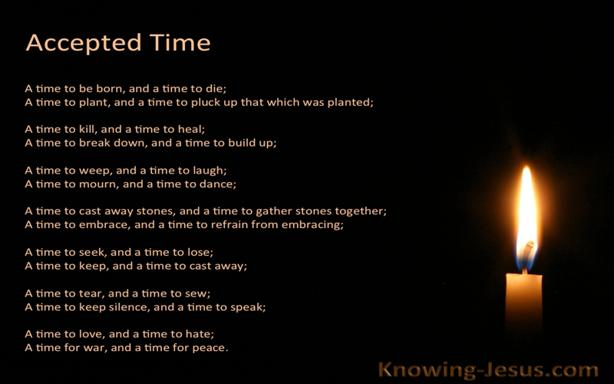What might be the intention behind the visual layout of this image? The stark simplicity of the visual layout, featuring just the text and a single candle against a dark background, serves to enhance focus on the message. This setting aims to evoke contemplation and meditation, drawing the viewer's attention to the profoundness of the words and allowing the symbolism of the candle to shine brightly as a beacon of hope and reflection. 